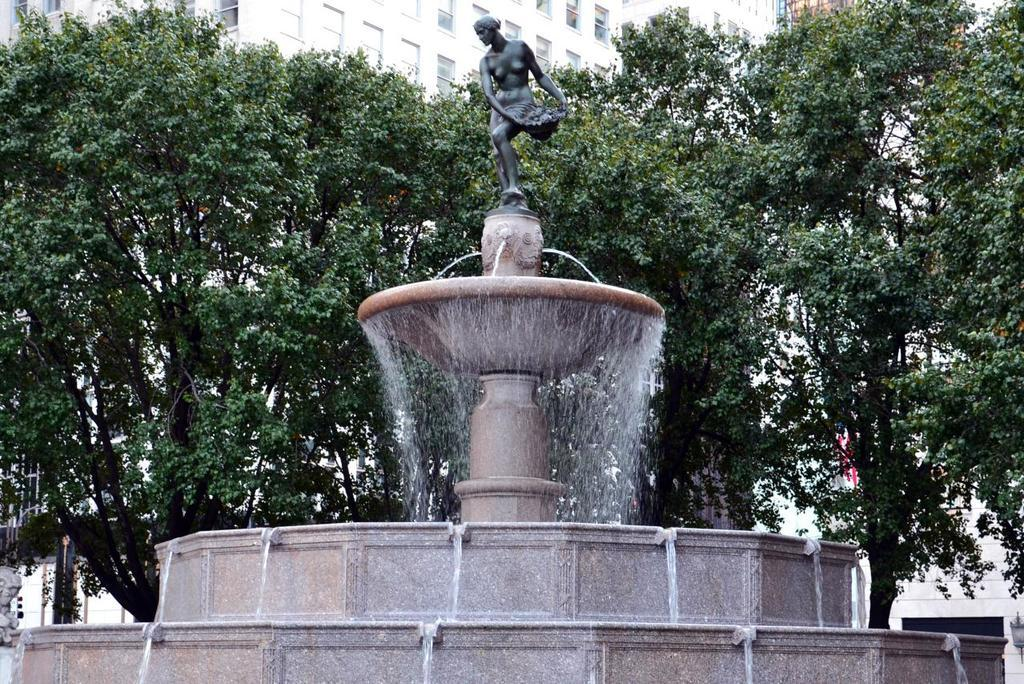What type of structure can be seen in the background of the image? There is a building with windows in the background of the image. What other natural elements are visible in the background? There are trees in the background of the image. What feature is present in the foreground of the image? There is a water fountain in the image. What type of object is on a pedestal in the image? There is a statue on a pedestal in the image. What type of business is being conducted in the image? There is no indication of a business being conducted in the image. --- Facts: 1. There is a person in the image. 2. The person is wearing a hat. 3. The person is holding a book. 4. There is a table in the image. 5. There is a chair in the image. Absurd Topics: parrot, bicycle Conversation: Who or what is present in the image? There is a person in the image. What is the person wearing in the image? The person is wearing a hat in the image. What is the person holding in the image? The person is holding a book in the image. What type of furniture is present in the image? There is a table and a chair in the image. Reasoning: Let's think step by step in order to produce the conversation. We start by identifying the main subject in the image, which is the person. Then, we describe specific features of the person, such as the hat and the book they are holding. Next, we observe the furniture in the image, noting the presence of a table and a chair. Each question is designed to elicit a specific detail about the image that is known from the provided facts. We avoid yes/no questions and ensure that the language is simple and clear. Absurd Question/Answer: Can you see a parrot flying in the image? There is no parrot flying in the image. Is the person riding a bicycle in the image? There is no bicycle present in the image. 